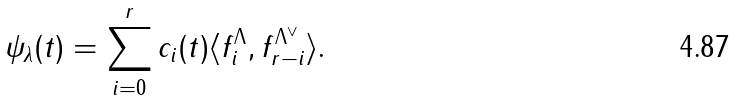<formula> <loc_0><loc_0><loc_500><loc_500>\psi _ { \lambda } ( t ) = \sum ^ { r } _ { i = 0 } c _ { i } ( t ) \langle f ^ { \Lambda } _ { i } , f ^ { \Lambda ^ { \vee } } _ { r - i } \rangle .</formula> 